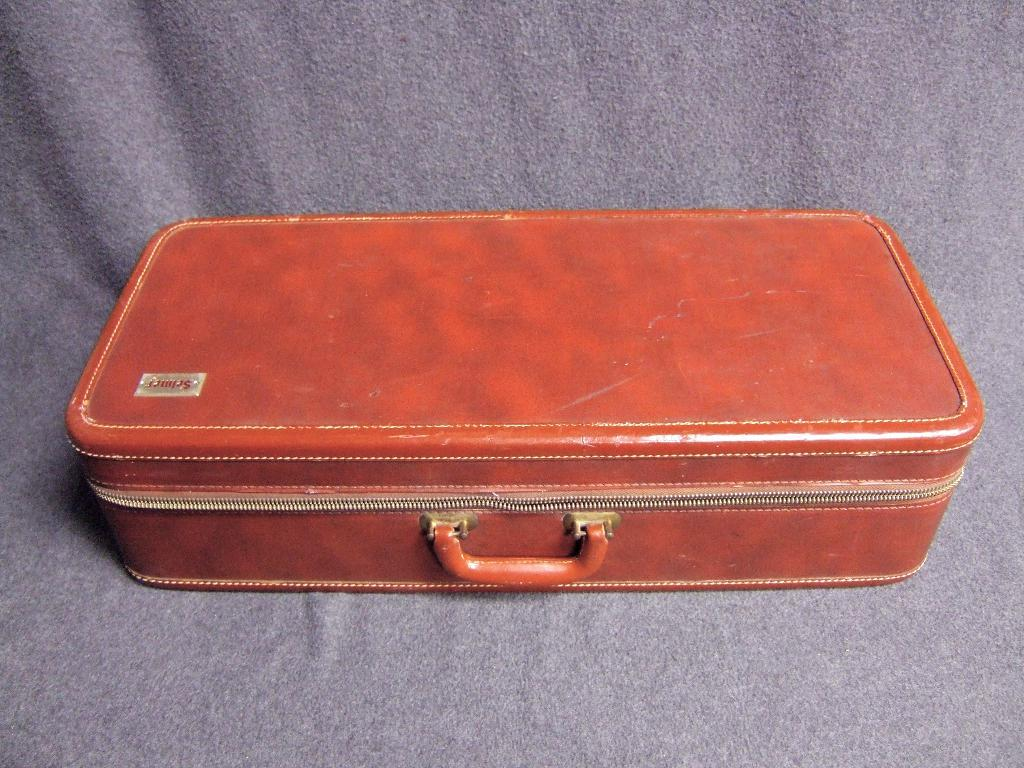What color is the suitcase that can be seen in the image? The suitcase in the image is red. How is the red suitcase being emphasized or made more noticeable in the image? The red suitcase is highlighted in the image. What is the condition of the stomach in the image? There is no mention of a stomach in the image. --- 